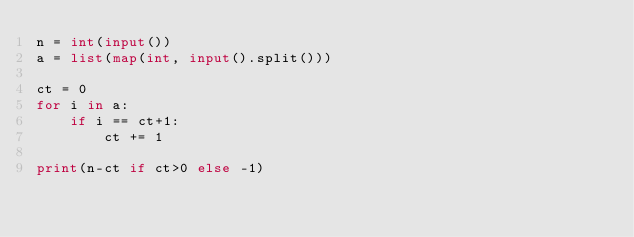<code> <loc_0><loc_0><loc_500><loc_500><_Python_>n = int(input())
a = list(map(int, input().split()))

ct = 0
for i in a:
    if i == ct+1:
        ct += 1

print(n-ct if ct>0 else -1)
</code> 